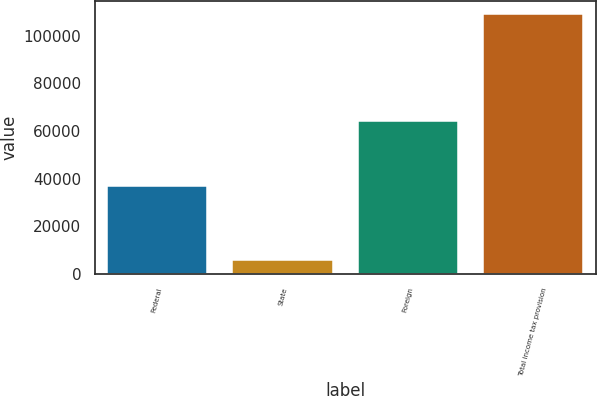<chart> <loc_0><loc_0><loc_500><loc_500><bar_chart><fcel>Federal<fcel>State<fcel>Foreign<fcel>Total income tax provision<nl><fcel>36771<fcel>5785<fcel>64109<fcel>109331<nl></chart> 